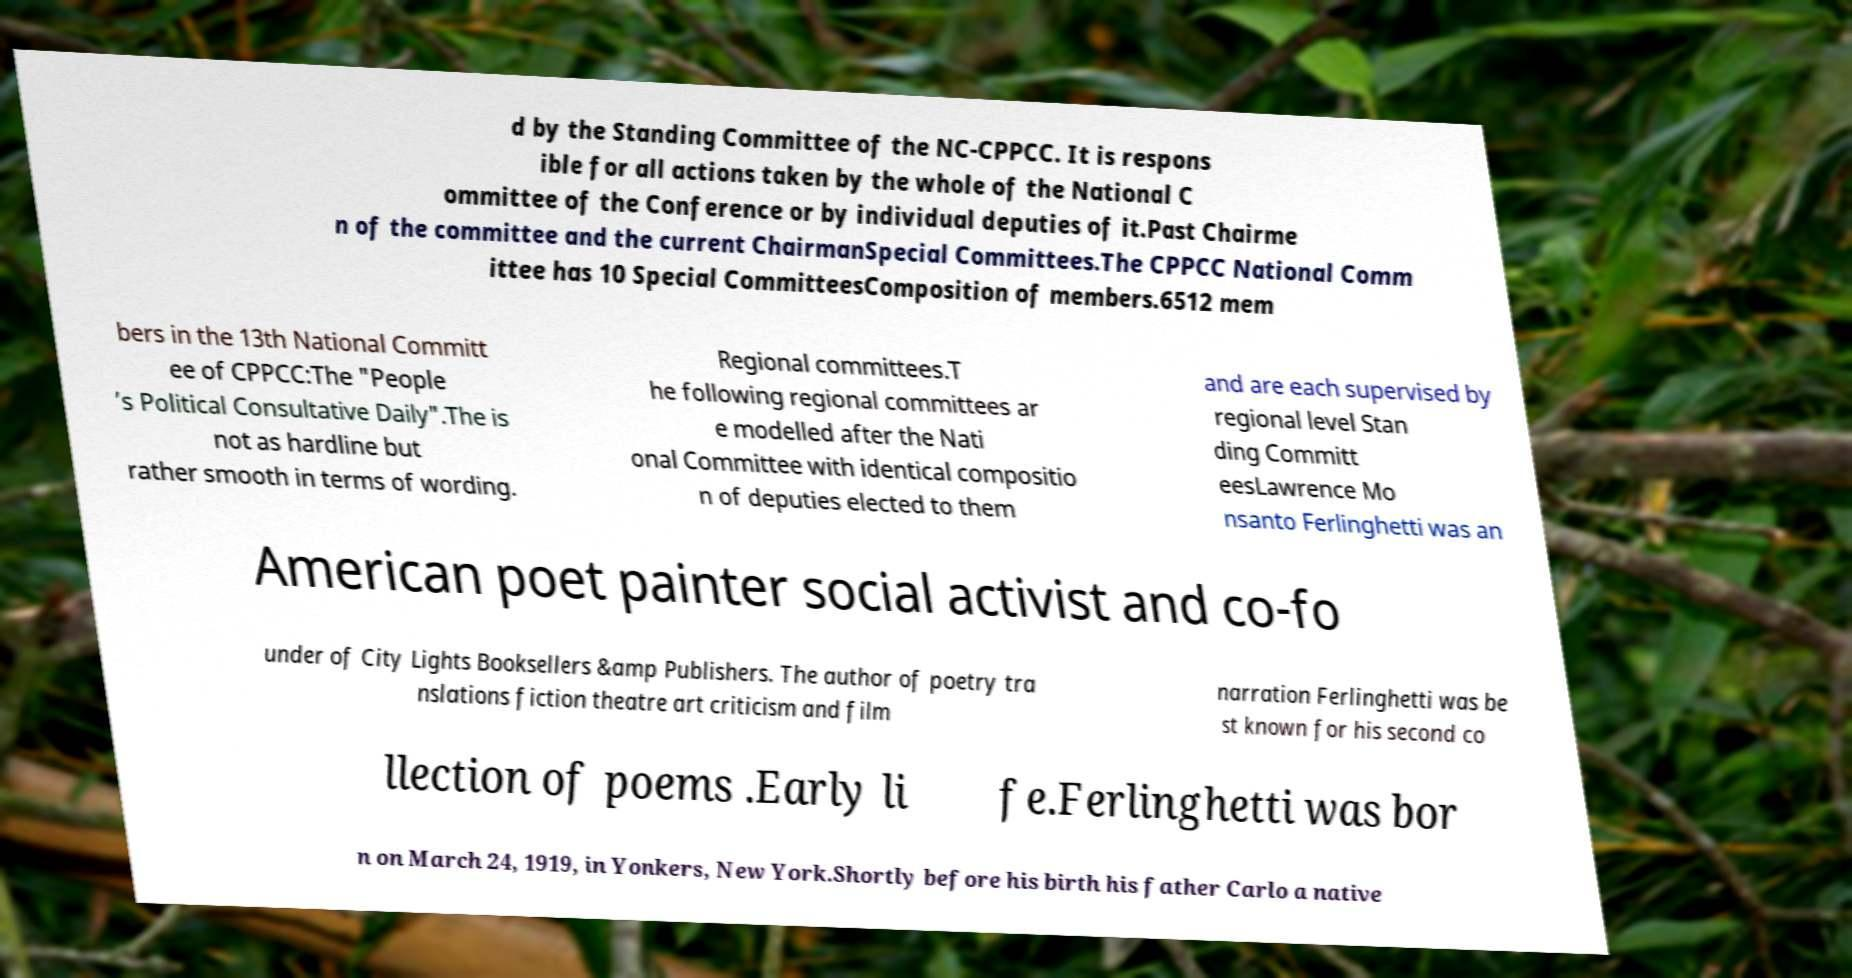Can you accurately transcribe the text from the provided image for me? d by the Standing Committee of the NC-CPPCC. It is respons ible for all actions taken by the whole of the National C ommittee of the Conference or by individual deputies of it.Past Chairme n of the committee and the current ChairmanSpecial Committees.The CPPCC National Comm ittee has 10 Special CommitteesComposition of members.6512 mem bers in the 13th National Committ ee of CPPCC:The "People ’s Political Consultative Daily".The is not as hardline but rather smooth in terms of wording. Regional committees.T he following regional committees ar e modelled after the Nati onal Committee with identical compositio n of deputies elected to them and are each supervised by regional level Stan ding Committ eesLawrence Mo nsanto Ferlinghetti was an American poet painter social activist and co-fo under of City Lights Booksellers &amp Publishers. The author of poetry tra nslations fiction theatre art criticism and film narration Ferlinghetti was be st known for his second co llection of poems .Early li fe.Ferlinghetti was bor n on March 24, 1919, in Yonkers, New York.Shortly before his birth his father Carlo a native 